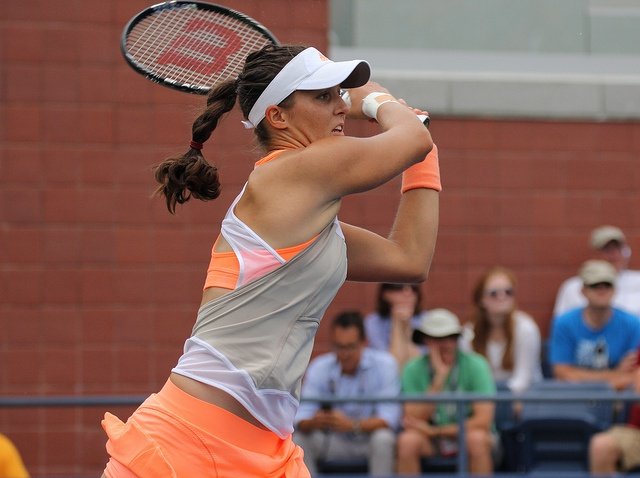Describe the objects in this image and their specific colors. I can see people in brown, darkgray, gray, salmon, and black tones, people in brown, gray, black, and teal tones, people in brown, gray, darkgray, and maroon tones, tennis racket in brown, darkgray, black, and gray tones, and people in brown, black, darkgray, maroon, and gray tones in this image. 